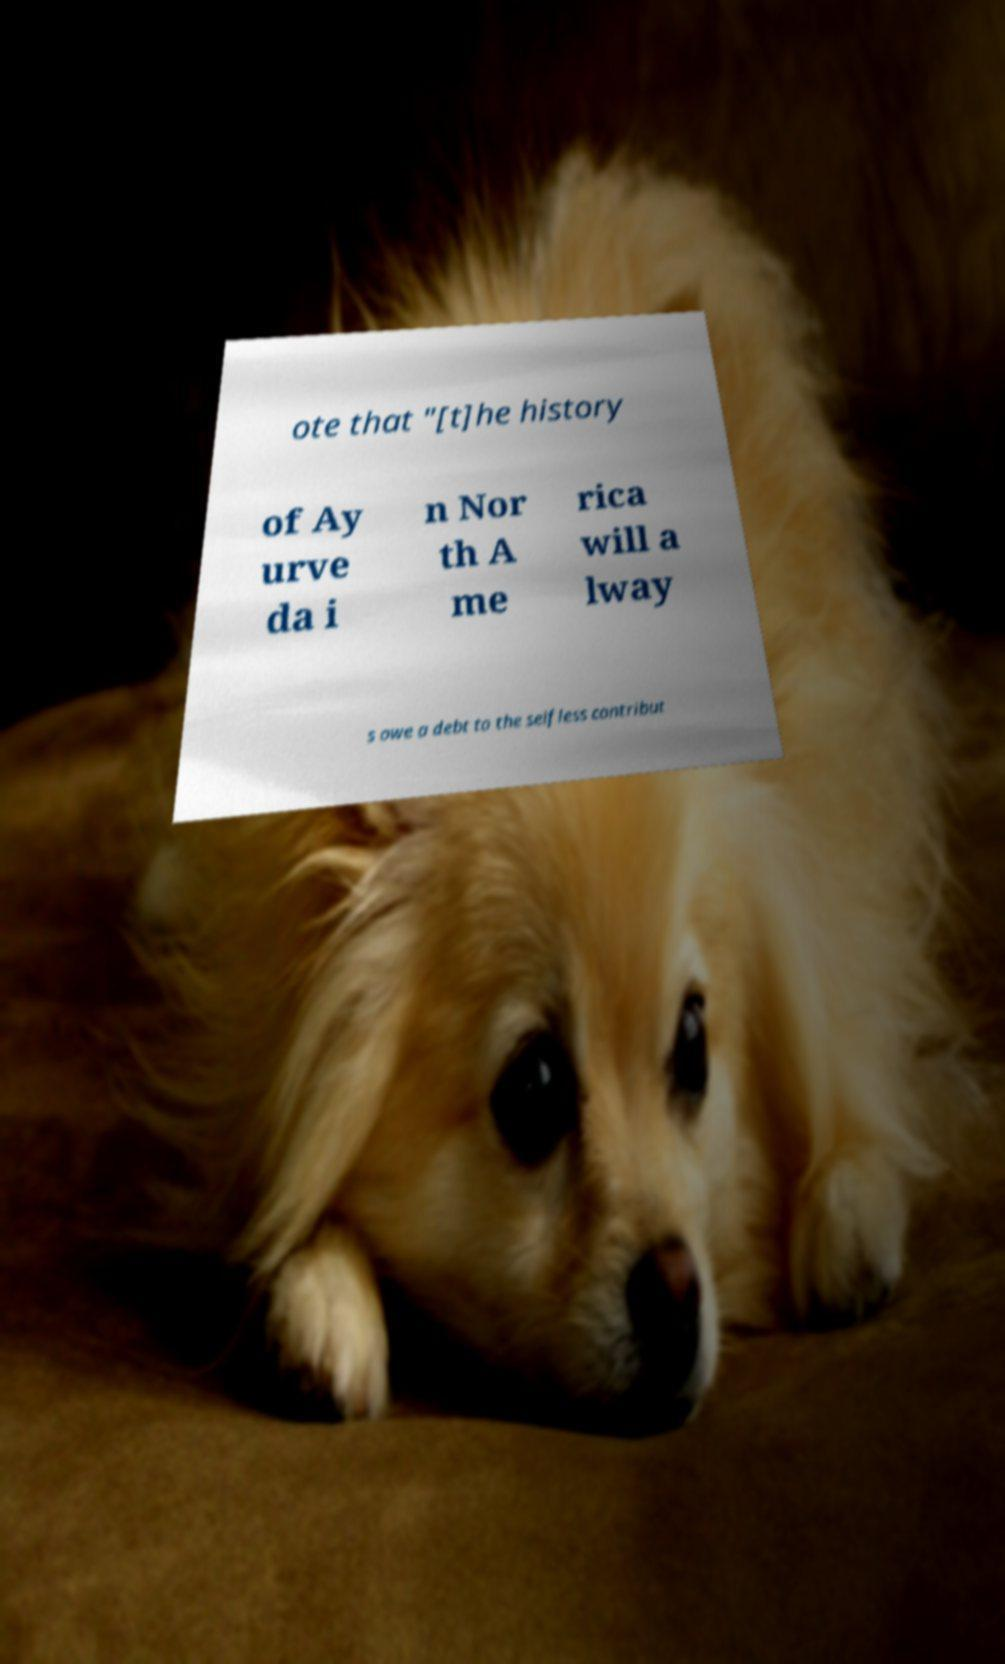Could you extract and type out the text from this image? ote that "[t]he history of Ay urve da i n Nor th A me rica will a lway s owe a debt to the selfless contribut 